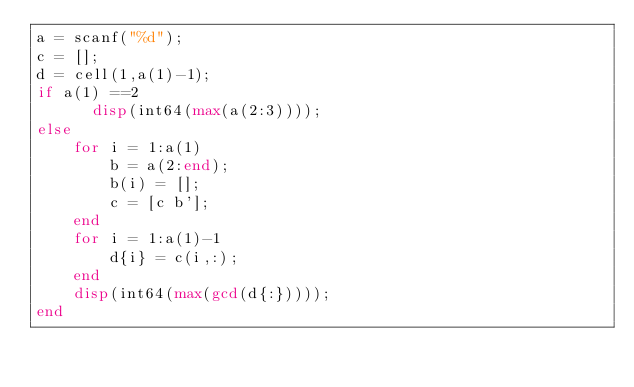<code> <loc_0><loc_0><loc_500><loc_500><_Octave_>a = scanf("%d");
c = [];
d = cell(1,a(1)-1);
if a(1) ==2
	  disp(int64(max(a(2:3))));
else
  	for i = 1:a(1)
    	b = a(2:end);
      	b(i) = [];
      	c = [c b'];
    end
    for i = 1:a(1)-1
      	d{i} = c(i,:);
    end
  	disp(int64(max(gcd(d{:}))));
end
</code> 